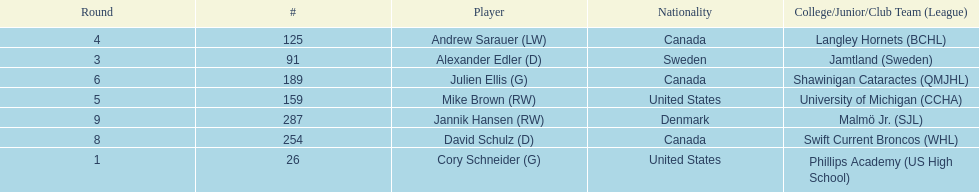How many players were from the united states? 2. 